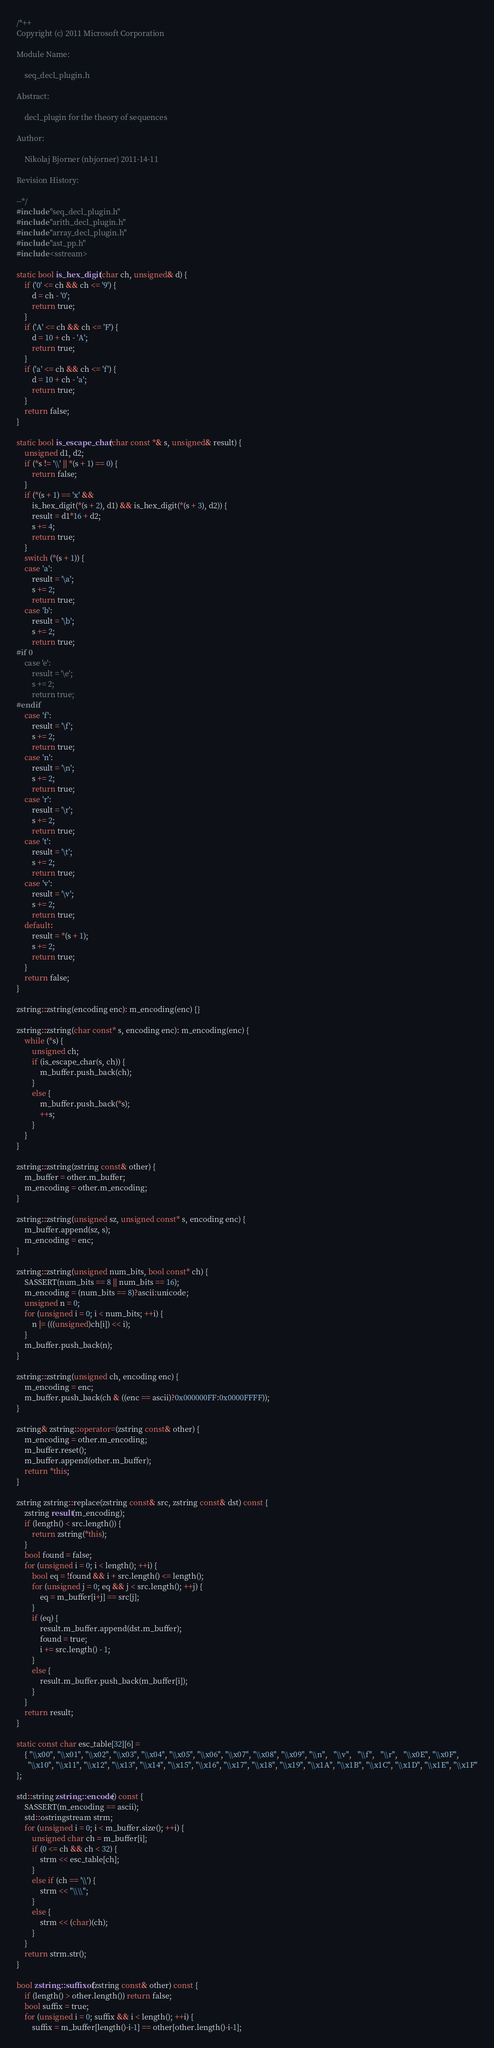Convert code to text. <code><loc_0><loc_0><loc_500><loc_500><_C++_>/*++
Copyright (c) 2011 Microsoft Corporation

Module Name:

    seq_decl_plugin.h

Abstract:

    decl_plugin for the theory of sequences

Author:

    Nikolaj Bjorner (nbjorner) 2011-14-11

Revision History:

--*/
#include "seq_decl_plugin.h"
#include "arith_decl_plugin.h"
#include "array_decl_plugin.h"
#include "ast_pp.h"
#include <sstream>

static bool is_hex_digit(char ch, unsigned& d) {
    if ('0' <= ch && ch <= '9') {
        d = ch - '0';
        return true;
    }
    if ('A' <= ch && ch <= 'F') {
        d = 10 + ch - 'A';
        return true;
    }
    if ('a' <= ch && ch <= 'f') {
        d = 10 + ch - 'a';
        return true;
    }
    return false;
}

static bool is_escape_char(char const *& s, unsigned& result) {
    unsigned d1, d2;
    if (*s != '\\' || *(s + 1) == 0) {
        return false;
    }
    if (*(s + 1) == 'x' &&
        is_hex_digit(*(s + 2), d1) && is_hex_digit(*(s + 3), d2)) {
        result = d1*16 + d2;
        s += 4;
        return true;
    }
    switch (*(s + 1)) {
    case 'a':
        result = '\a';
        s += 2;
        return true;
    case 'b':
        result = '\b';
        s += 2;
        return true;
#if 0
    case 'e':
        result = '\e';
        s += 2;
        return true;
#endif
    case 'f':
        result = '\f';
        s += 2;
        return true;
    case 'n':
        result = '\n';
        s += 2;
        return true;
    case 'r':
        result = '\r';
        s += 2;
        return true;
    case 't':
        result = '\t';
        s += 2;
        return true;
    case 'v':
        result = '\v';
        s += 2;
        return true;
    default:
        result = *(s + 1);
        s += 2;
        return true;
    }
    return false;
}

zstring::zstring(encoding enc): m_encoding(enc) {}

zstring::zstring(char const* s, encoding enc): m_encoding(enc) {
    while (*s) {
        unsigned ch;
        if (is_escape_char(s, ch)) {
            m_buffer.push_back(ch);
        }
        else {
            m_buffer.push_back(*s);
            ++s;
        }
    }
}

zstring::zstring(zstring const& other) {
    m_buffer = other.m_buffer;
    m_encoding = other.m_encoding;
}

zstring::zstring(unsigned sz, unsigned const* s, encoding enc) {
    m_buffer.append(sz, s);
    m_encoding = enc;
}

zstring::zstring(unsigned num_bits, bool const* ch) {
    SASSERT(num_bits == 8 || num_bits == 16);
    m_encoding = (num_bits == 8)?ascii:unicode;
    unsigned n = 0;
    for (unsigned i = 0; i < num_bits; ++i) {
        n |= (((unsigned)ch[i]) << i);
    }
    m_buffer.push_back(n);
}

zstring::zstring(unsigned ch, encoding enc) {
    m_encoding = enc;
    m_buffer.push_back(ch & ((enc == ascii)?0x000000FF:0x0000FFFF));
}

zstring& zstring::operator=(zstring const& other) {
    m_encoding = other.m_encoding;
    m_buffer.reset();
    m_buffer.append(other.m_buffer);
    return *this;
}

zstring zstring::replace(zstring const& src, zstring const& dst) const {
    zstring result(m_encoding);
    if (length() < src.length()) {
        return zstring(*this);
    }
    bool found = false;
    for (unsigned i = 0; i < length(); ++i) {
        bool eq = !found && i + src.length() <= length();
        for (unsigned j = 0; eq && j < src.length(); ++j) {
            eq = m_buffer[i+j] == src[j];
        }
        if (eq) {
            result.m_buffer.append(dst.m_buffer);
            found = true;
            i += src.length() - 1;
        }
        else {
            result.m_buffer.push_back(m_buffer[i]);
        }
    }
    return result;
}

static const char esc_table[32][6] =
    { "\\x00", "\\x01", "\\x02", "\\x03", "\\x04", "\\x05", "\\x06", "\\x07", "\\x08", "\\x09", "\\n",   "\\v",   "\\f",   "\\r",   "\\x0E", "\\x0F",
      "\\x10", "\\x11", "\\x12", "\\x13", "\\x14", "\\x15", "\\x16", "\\x17", "\\x18", "\\x19", "\\x1A", "\\x1B", "\\x1C", "\\x1D", "\\x1E", "\\x1F"
};

std::string zstring::encode() const {
    SASSERT(m_encoding == ascii);
    std::ostringstream strm;
    for (unsigned i = 0; i < m_buffer.size(); ++i) {
        unsigned char ch = m_buffer[i];
        if (0 <= ch && ch < 32) {
            strm << esc_table[ch];
        }
        else if (ch == '\\') {
            strm << "\\\\";
        }
        else {
            strm << (char)(ch);
        }
    }
    return strm.str();
}

bool zstring::suffixof(zstring const& other) const {
    if (length() > other.length()) return false;
    bool suffix = true;
    for (unsigned i = 0; suffix && i < length(); ++i) {
        suffix = m_buffer[length()-i-1] == other[other.length()-i-1];</code> 